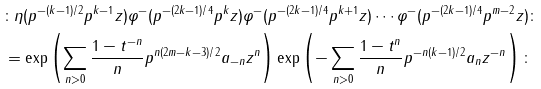Convert formula to latex. <formula><loc_0><loc_0><loc_500><loc_500>& \colon \eta ( p ^ { - ( k - 1 ) / 2 } p ^ { k - 1 } z ) \varphi ^ { - } ( p ^ { - ( 2 k - 1 ) / 4 } p ^ { k } z ) \varphi ^ { - } ( p ^ { - ( 2 k - 1 ) / 4 } p ^ { k + 1 } z ) \cdots \varphi ^ { - } ( p ^ { - ( 2 k - 1 ) / 4 } p ^ { m - 2 } z ) \colon \\ & = \exp \left ( \sum _ { n > 0 } \frac { 1 - t ^ { - n } } { n } p ^ { n ( 2 m - k - 3 ) / 2 } a _ { - n } z ^ { n } \right ) \exp \left ( - \sum _ { n > 0 } \frac { 1 - t ^ { n } } { n } p ^ { - n ( k - 1 ) / 2 } a _ { n } z ^ { - n } \right ) \colon</formula> 